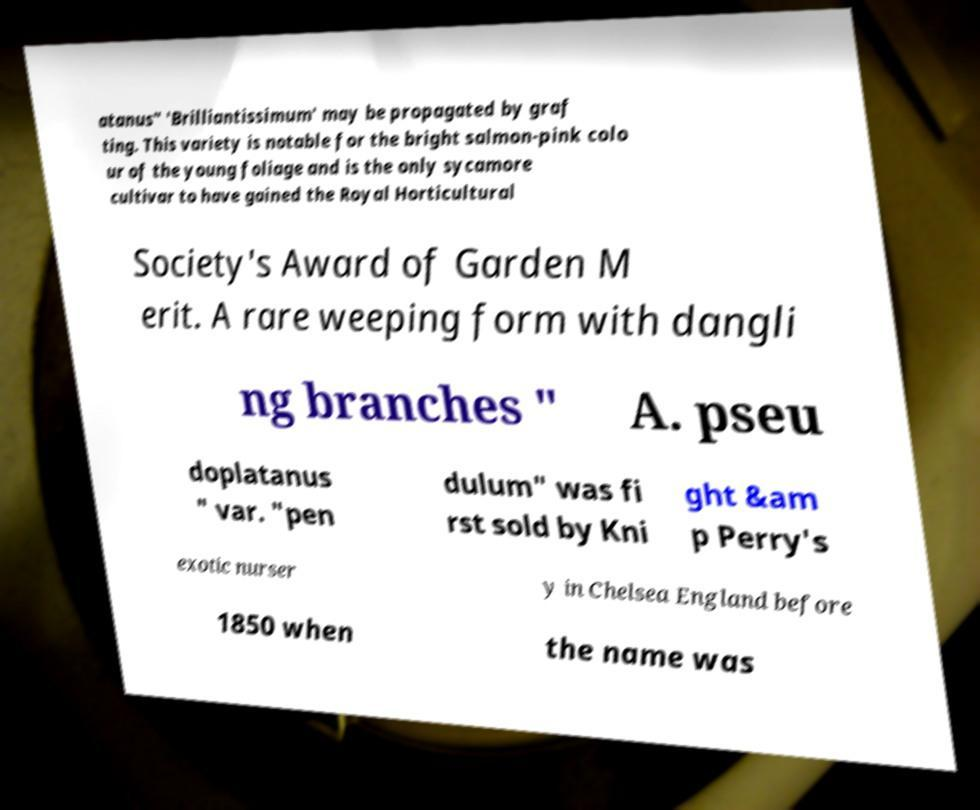Can you read and provide the text displayed in the image?This photo seems to have some interesting text. Can you extract and type it out for me? atanus" 'Brilliantissimum' may be propagated by graf ting. This variety is notable for the bright salmon-pink colo ur of the young foliage and is the only sycamore cultivar to have gained the Royal Horticultural Society's Award of Garden M erit. A rare weeping form with dangli ng branches " A. pseu doplatanus " var. "pen dulum" was fi rst sold by Kni ght &am p Perry's exotic nurser y in Chelsea England before 1850 when the name was 